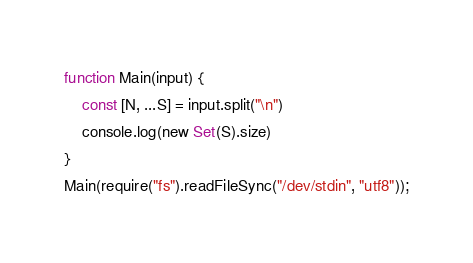Convert code to text. <code><loc_0><loc_0><loc_500><loc_500><_TypeScript_>function Main(input) {
    const [N, ...S] = input.split("\n")
    console.log(new Set(S).size)
}
Main(require("fs").readFileSync("/dev/stdin", "utf8"));
</code> 